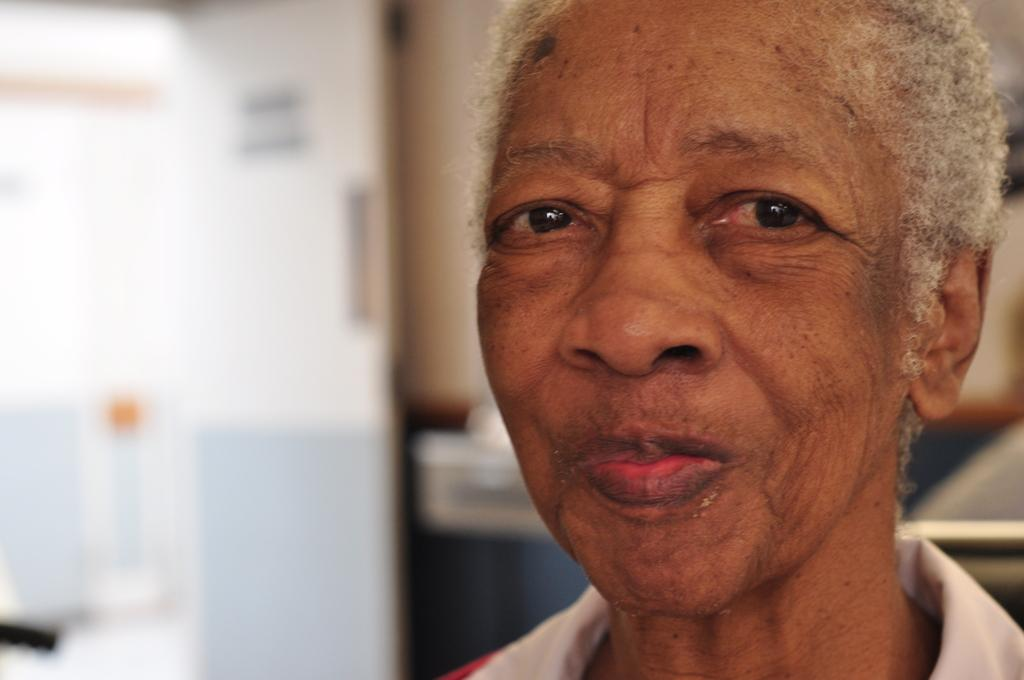What is the main subject of the image? There is a person in the image. Can you describe the background of the image? The background of the image is blurred. What type of disgust can be seen on the person's face in the image? There is no indication of disgust on the person's face in the image. Is there a river visible in the background of the image? There is no river present in the image; the background is blurred. 